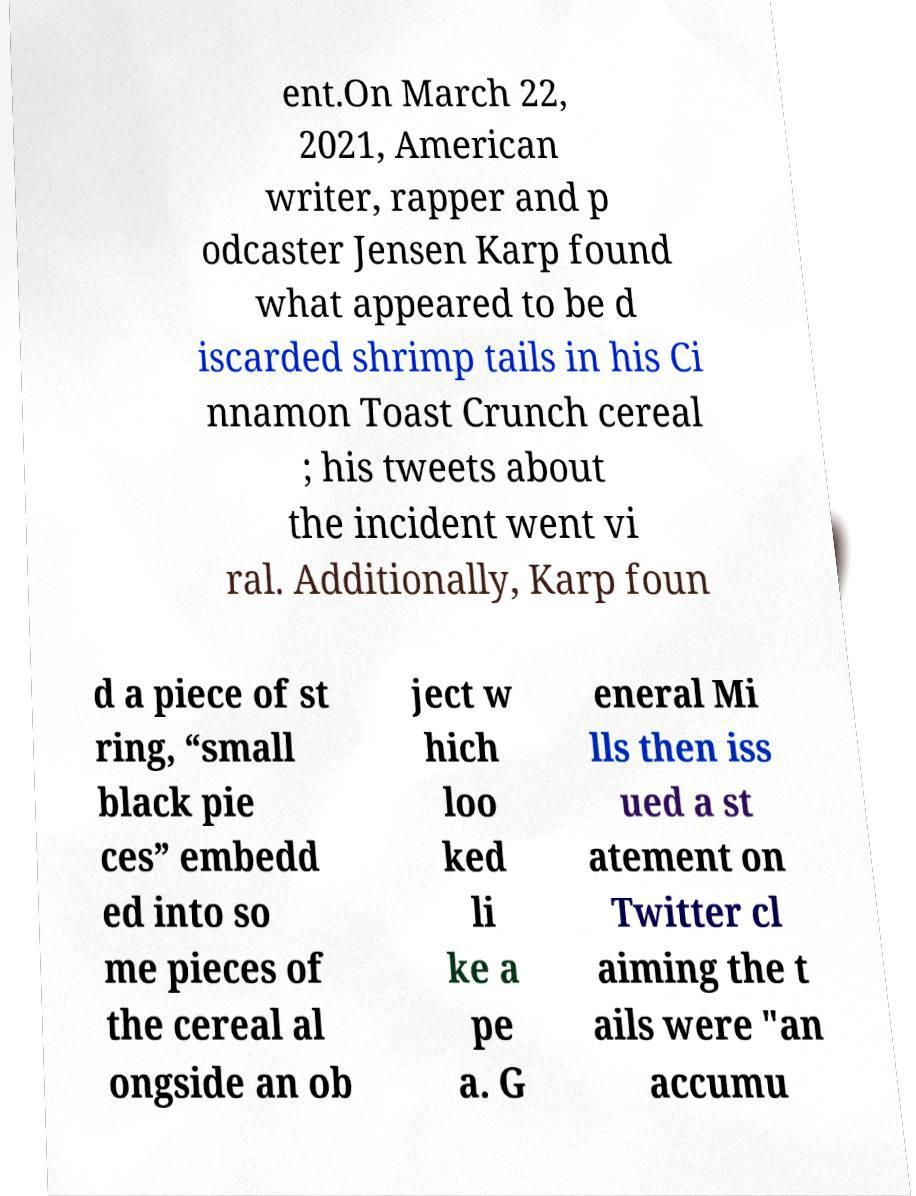There's text embedded in this image that I need extracted. Can you transcribe it verbatim? ent.On March 22, 2021, American writer, rapper and p odcaster Jensen Karp found what appeared to be d iscarded shrimp tails in his Ci nnamon Toast Crunch cereal ; his tweets about the incident went vi ral. Additionally, Karp foun d a piece of st ring, “small black pie ces” embedd ed into so me pieces of the cereal al ongside an ob ject w hich loo ked li ke a pe a. G eneral Mi lls then iss ued a st atement on Twitter cl aiming the t ails were "an accumu 